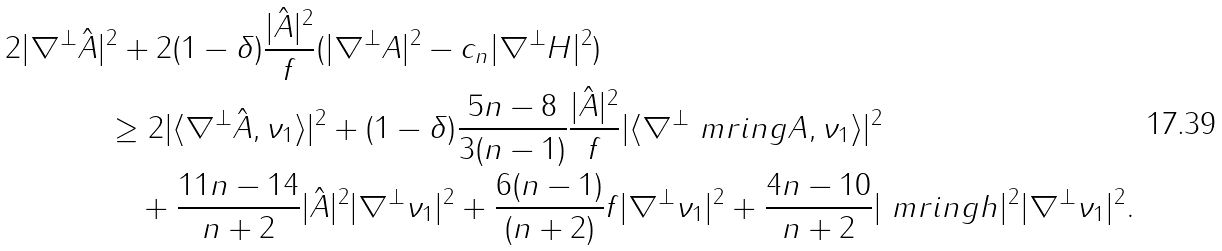<formula> <loc_0><loc_0><loc_500><loc_500>2 | \nabla ^ { \perp } \hat { A } | & ^ { 2 } + 2 ( 1 - \delta ) \frac { | \hat { A } | ^ { 2 } } { f } ( | \nabla ^ { \perp } A | ^ { 2 } - c _ { n } | \nabla ^ { \perp } H | ^ { 2 } ) \\ & \geq 2 | \langle \nabla ^ { \perp } \hat { A } , \nu _ { 1 } \rangle | ^ { 2 } + ( 1 - \delta ) \frac { 5 n - 8 } { 3 ( n - 1 ) } \frac { | \hat { A } | ^ { 2 } } { f } | \langle \nabla ^ { \perp } \ m r i n g A , \nu _ { 1 } \rangle | ^ { 2 } \\ & \quad + \frac { 1 1 n - 1 4 } { n + 2 } | \hat { A } | ^ { 2 } | \nabla ^ { \perp } \nu _ { 1 } | ^ { 2 } + \frac { 6 ( n - 1 ) } { ( n + 2 ) } f | \nabla ^ { \perp } \nu _ { 1 } | ^ { 2 } + \frac { 4 n - 1 0 } { n + 2 } | \ m r i n g h | ^ { 2 } | \nabla ^ { \perp } \nu _ { 1 } | ^ { 2 } .</formula> 